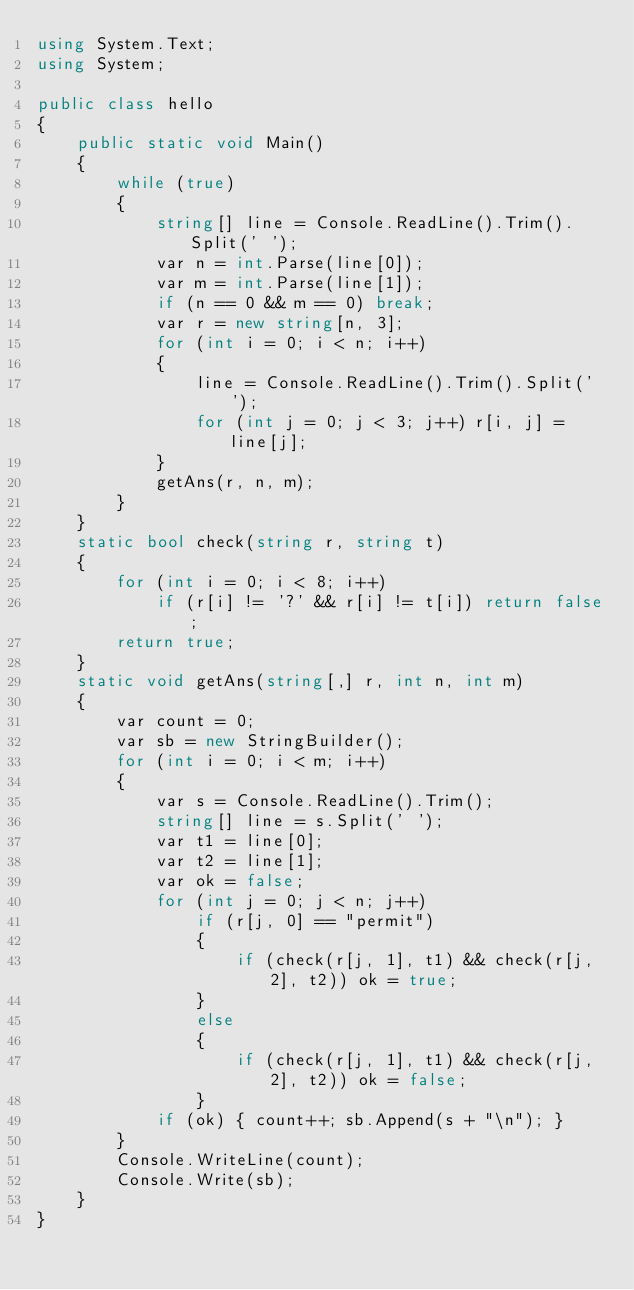Convert code to text. <code><loc_0><loc_0><loc_500><loc_500><_C#_>using System.Text;
using System;

public class hello
{
    public static void Main()
    {
        while (true)
        {
            string[] line = Console.ReadLine().Trim().Split(' ');
            var n = int.Parse(line[0]);
            var m = int.Parse(line[1]);
            if (n == 0 && m == 0) break;
            var r = new string[n, 3];
            for (int i = 0; i < n; i++)
            {
                line = Console.ReadLine().Trim().Split(' ');
                for (int j = 0; j < 3; j++) r[i, j] = line[j];
            }
            getAns(r, n, m);
        }
    }
    static bool check(string r, string t)
    {
        for (int i = 0; i < 8; i++)
            if (r[i] != '?' && r[i] != t[i]) return false;
        return true;
    }
    static void getAns(string[,] r, int n, int m)
    {
        var count = 0;
        var sb = new StringBuilder();
        for (int i = 0; i < m; i++)
        {
            var s = Console.ReadLine().Trim();
            string[] line = s.Split(' ');
            var t1 = line[0];
            var t2 = line[1];
            var ok = false;
            for (int j = 0; j < n; j++)
                if (r[j, 0] == "permit")
                {
                    if (check(r[j, 1], t1) && check(r[j, 2], t2)) ok = true;
                }
                else
                {
                    if (check(r[j, 1], t1) && check(r[j, 2], t2)) ok = false;
                }
            if (ok) { count++; sb.Append(s + "\n"); }
        }
        Console.WriteLine(count);
        Console.Write(sb);
    }
}
</code> 